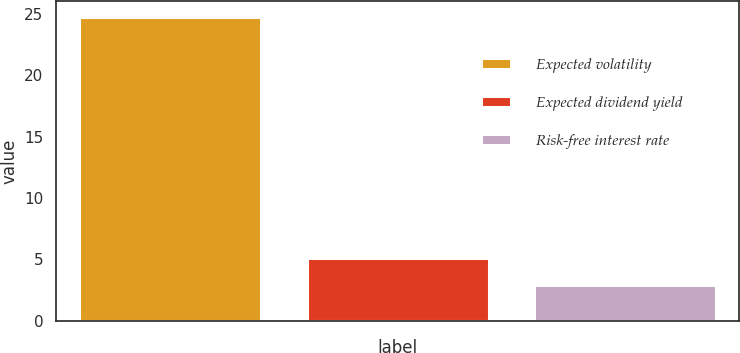Convert chart. <chart><loc_0><loc_0><loc_500><loc_500><bar_chart><fcel>Expected volatility<fcel>Expected dividend yield<fcel>Risk-free interest rate<nl><fcel>24.8<fcel>5.09<fcel>2.9<nl></chart> 